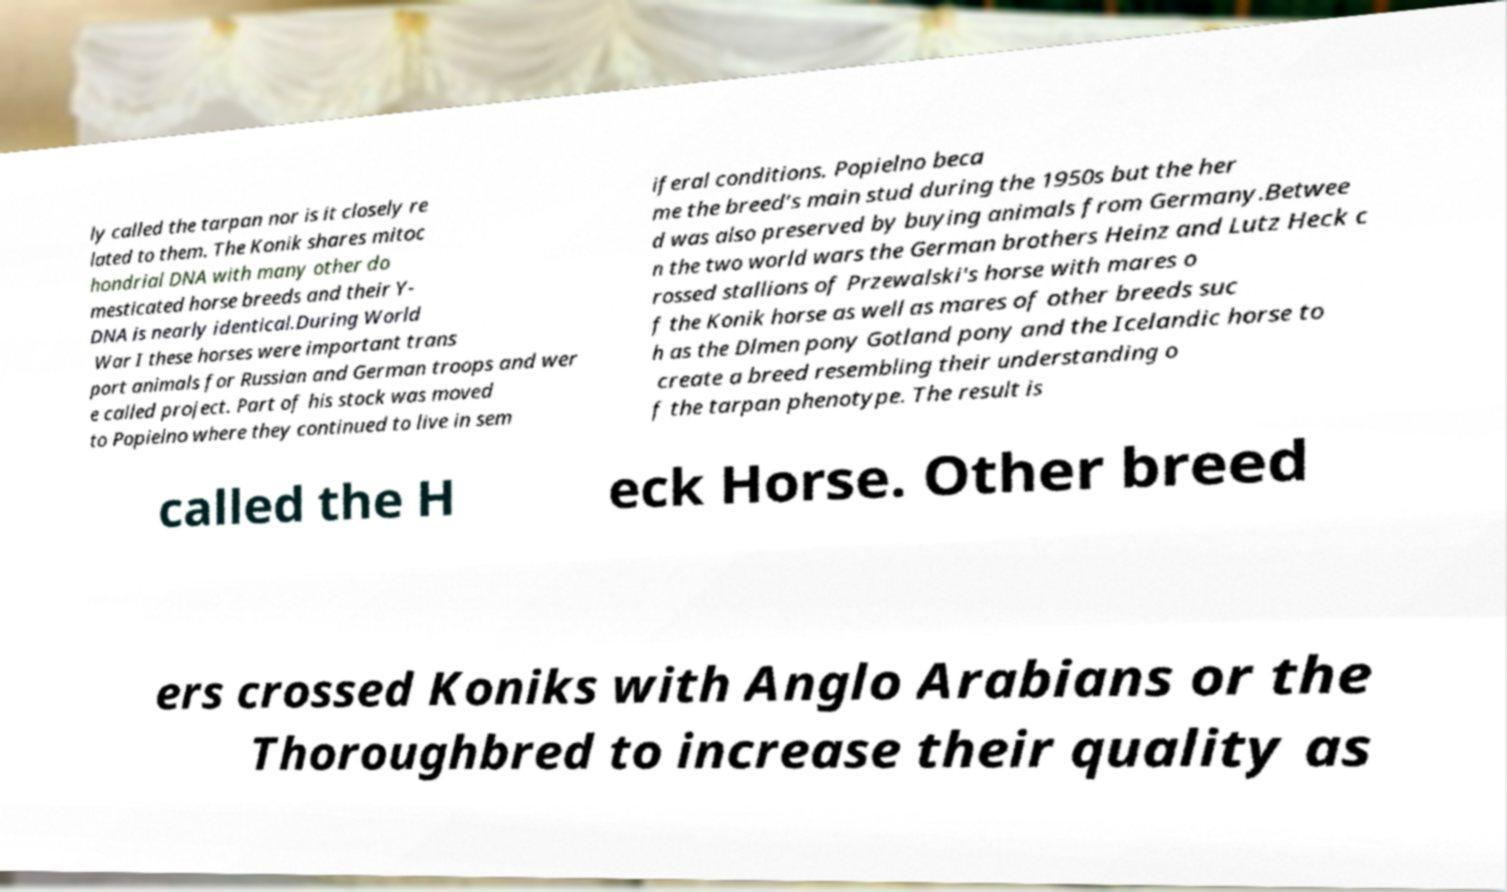Can you accurately transcribe the text from the provided image for me? ly called the tarpan nor is it closely re lated to them. The Konik shares mitoc hondrial DNA with many other do mesticated horse breeds and their Y- DNA is nearly identical.During World War I these horses were important trans port animals for Russian and German troops and wer e called project. Part of his stock was moved to Popielno where they continued to live in sem iferal conditions. Popielno beca me the breed’s main stud during the 1950s but the her d was also preserved by buying animals from Germany.Betwee n the two world wars the German brothers Heinz and Lutz Heck c rossed stallions of Przewalski's horse with mares o f the Konik horse as well as mares of other breeds suc h as the Dlmen pony Gotland pony and the Icelandic horse to create a breed resembling their understanding o f the tarpan phenotype. The result is called the H eck Horse. Other breed ers crossed Koniks with Anglo Arabians or the Thoroughbred to increase their quality as 